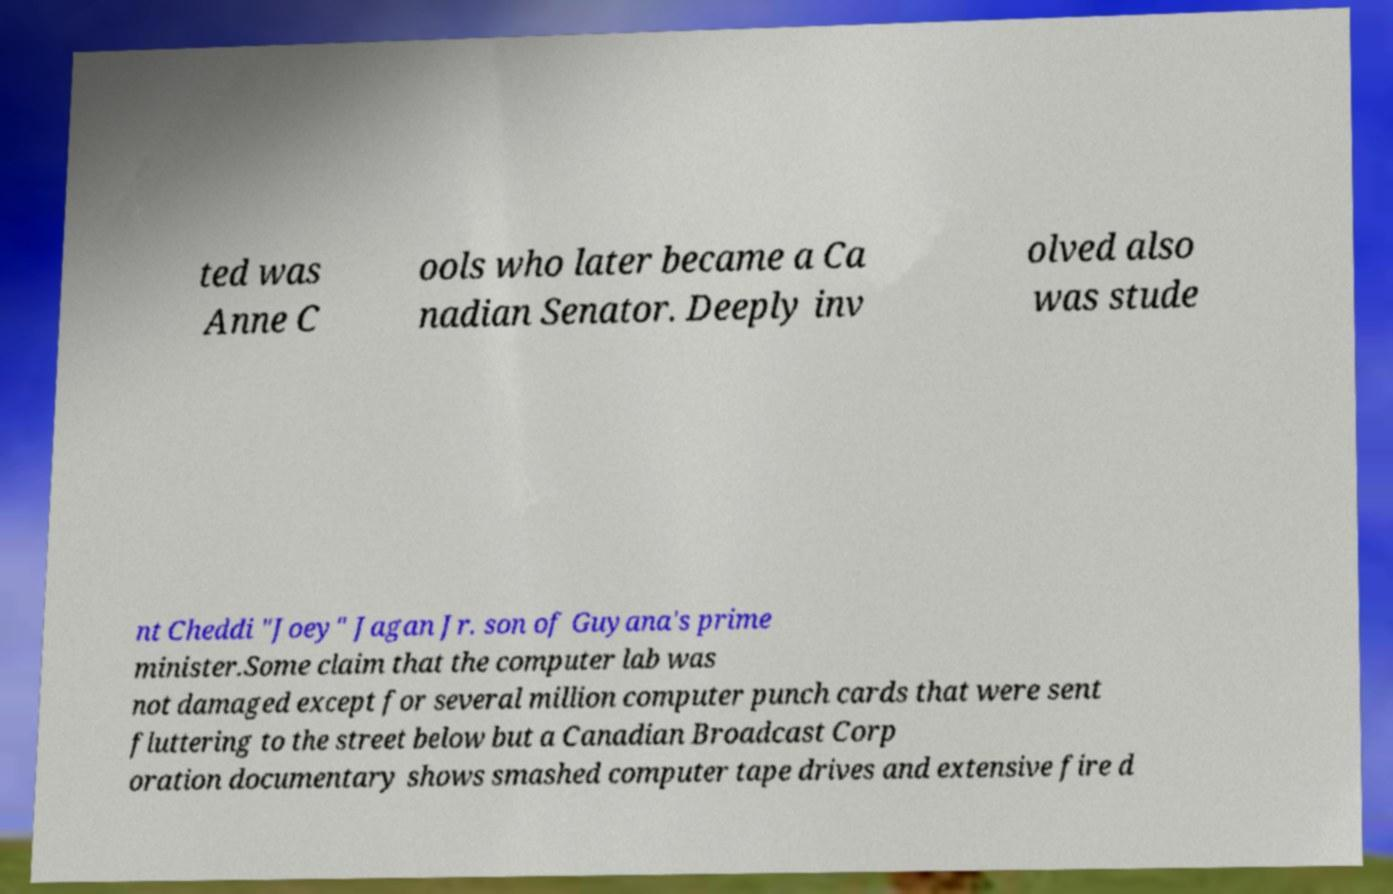Can you accurately transcribe the text from the provided image for me? ted was Anne C ools who later became a Ca nadian Senator. Deeply inv olved also was stude nt Cheddi "Joey" Jagan Jr. son of Guyana's prime minister.Some claim that the computer lab was not damaged except for several million computer punch cards that were sent fluttering to the street below but a Canadian Broadcast Corp oration documentary shows smashed computer tape drives and extensive fire d 